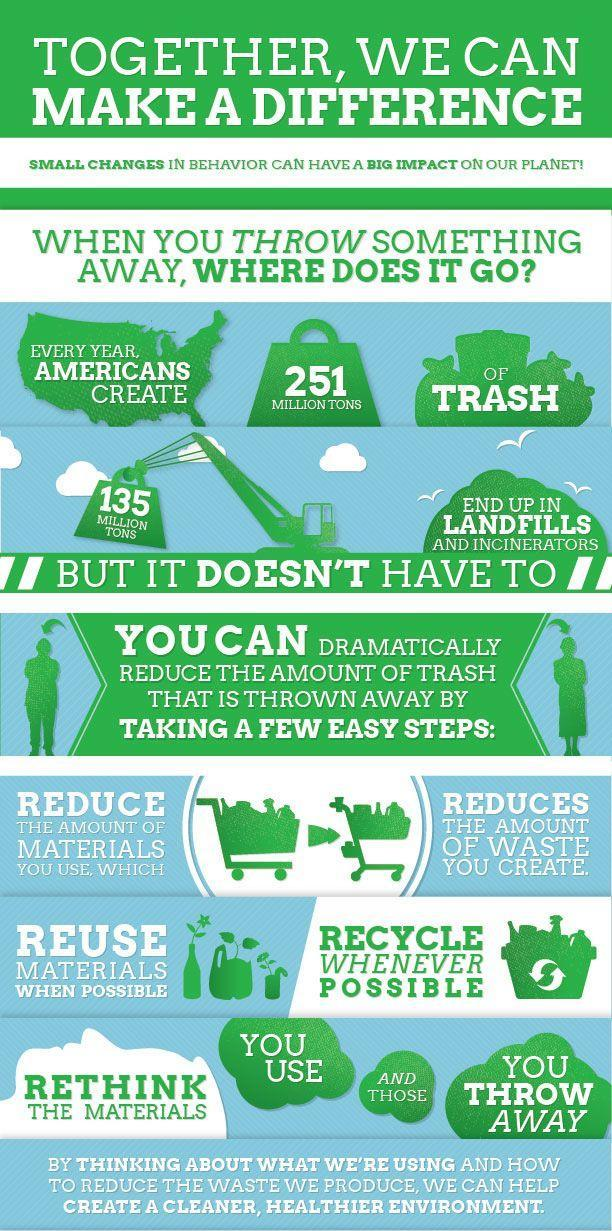How much of trash end up in landfills and incinerators?
Answer the question with a short phrase. 135 MILLION TONS How much trash is created every year by Americans? 251 MILLION TONS 